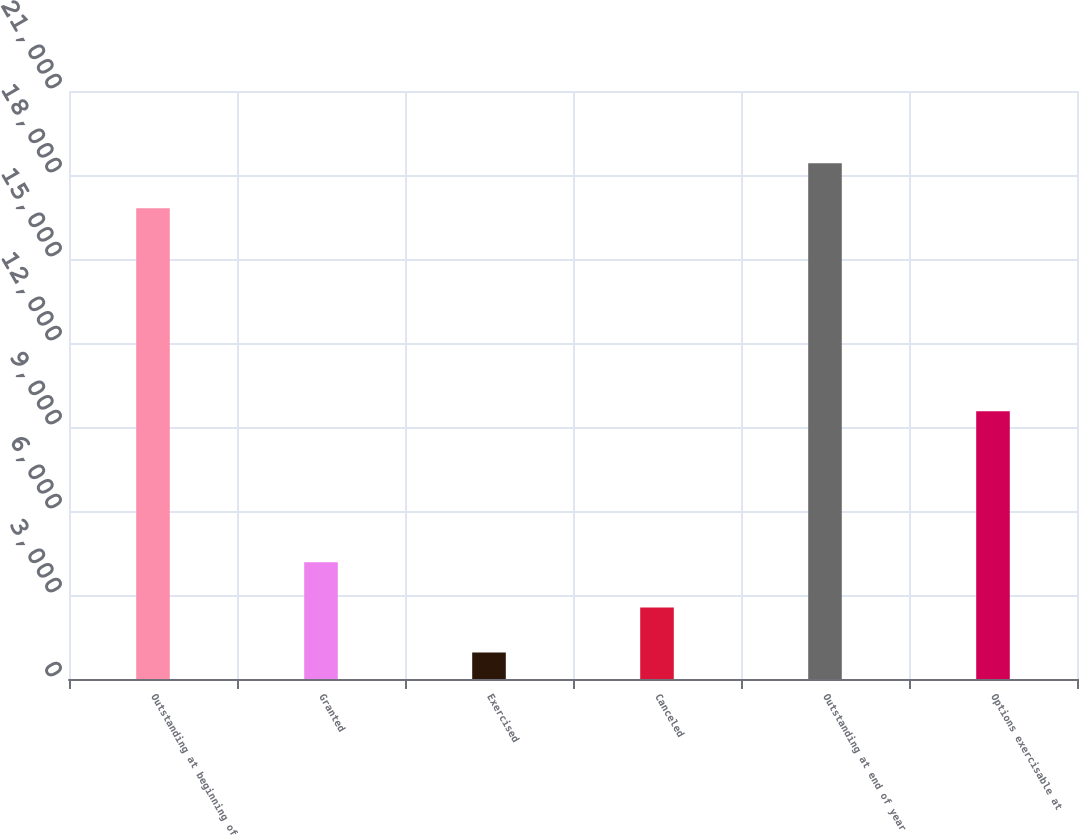Convert chart to OTSL. <chart><loc_0><loc_0><loc_500><loc_500><bar_chart><fcel>Outstanding at beginning of<fcel>Granted<fcel>Exercised<fcel>Canceled<fcel>Outstanding at end of year<fcel>Options exercisable at<nl><fcel>16810<fcel>4168.2<fcel>944<fcel>2556.1<fcel>18422.1<fcel>9566<nl></chart> 